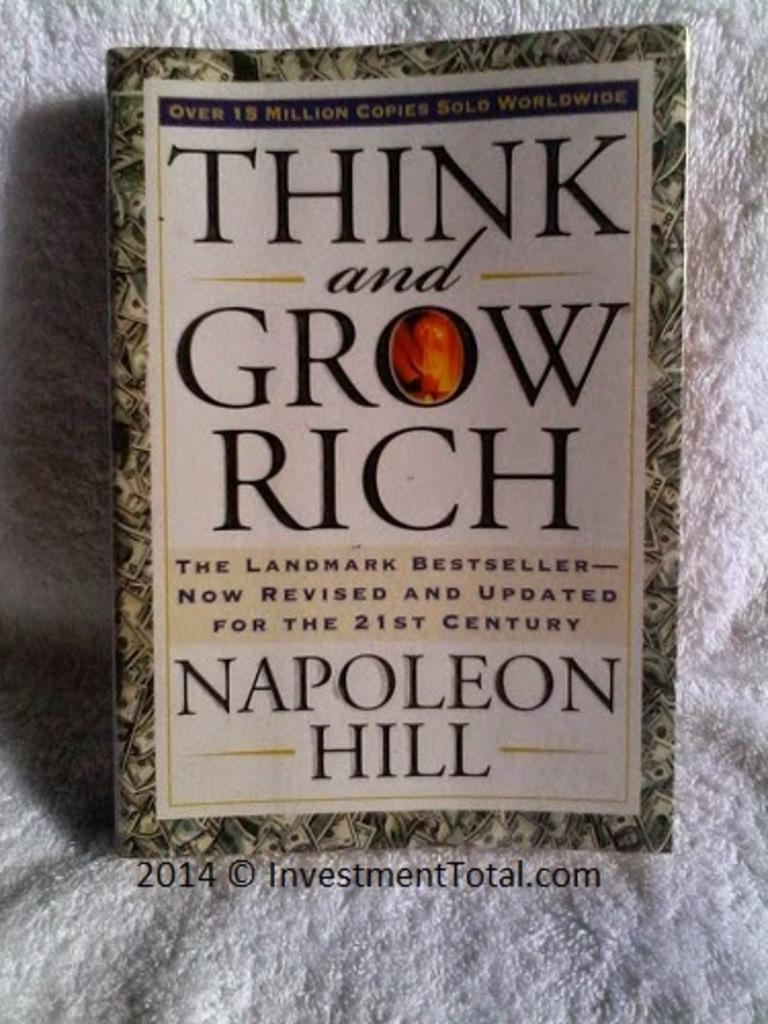Provide a one-sentence caption for the provided image. A book called Think and Grow Rich by Napoleon Hill. 